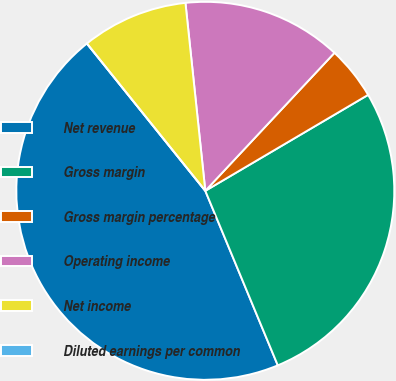Convert chart. <chart><loc_0><loc_0><loc_500><loc_500><pie_chart><fcel>Net revenue<fcel>Gross margin<fcel>Gross margin percentage<fcel>Operating income<fcel>Net income<fcel>Diluted earnings per common<nl><fcel>45.49%<fcel>27.21%<fcel>4.55%<fcel>13.65%<fcel>9.1%<fcel>0.0%<nl></chart> 